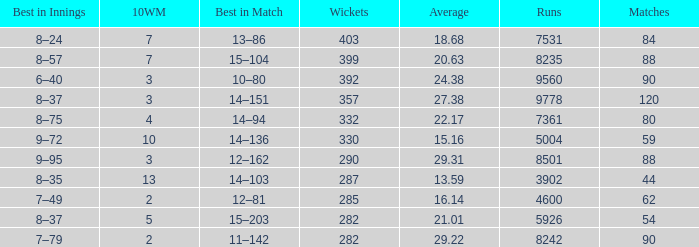What is the aggregate sum of wickets possessing under 4600 runs and less than 44 contests? None. 